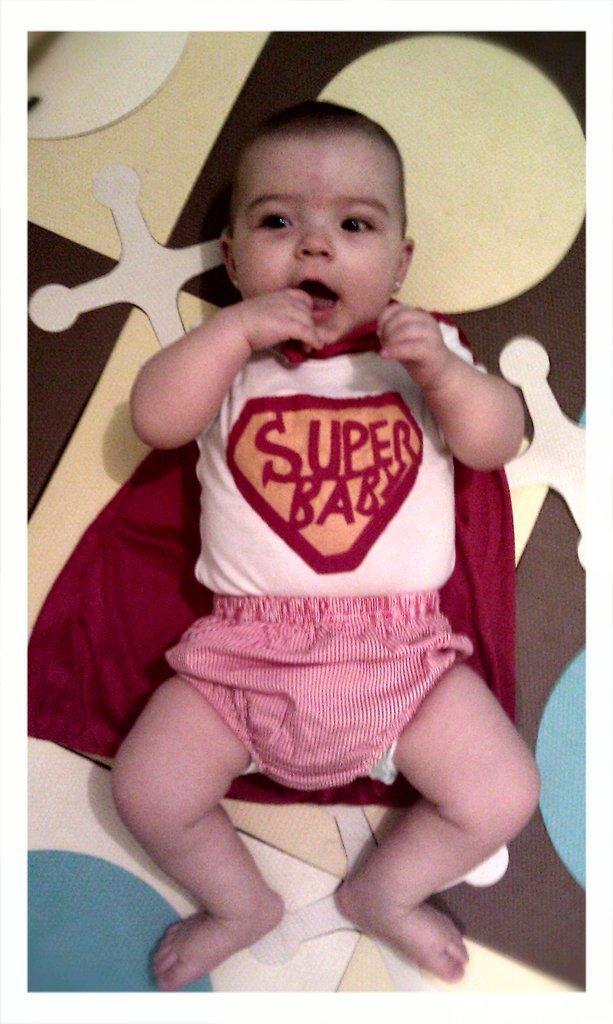Can you describe this image briefly? In this picture, we see a baby is lying on the bed. The baby is smiling. In the background, it is in white, yellow, brown and blue color. It might be a bed sheet. 